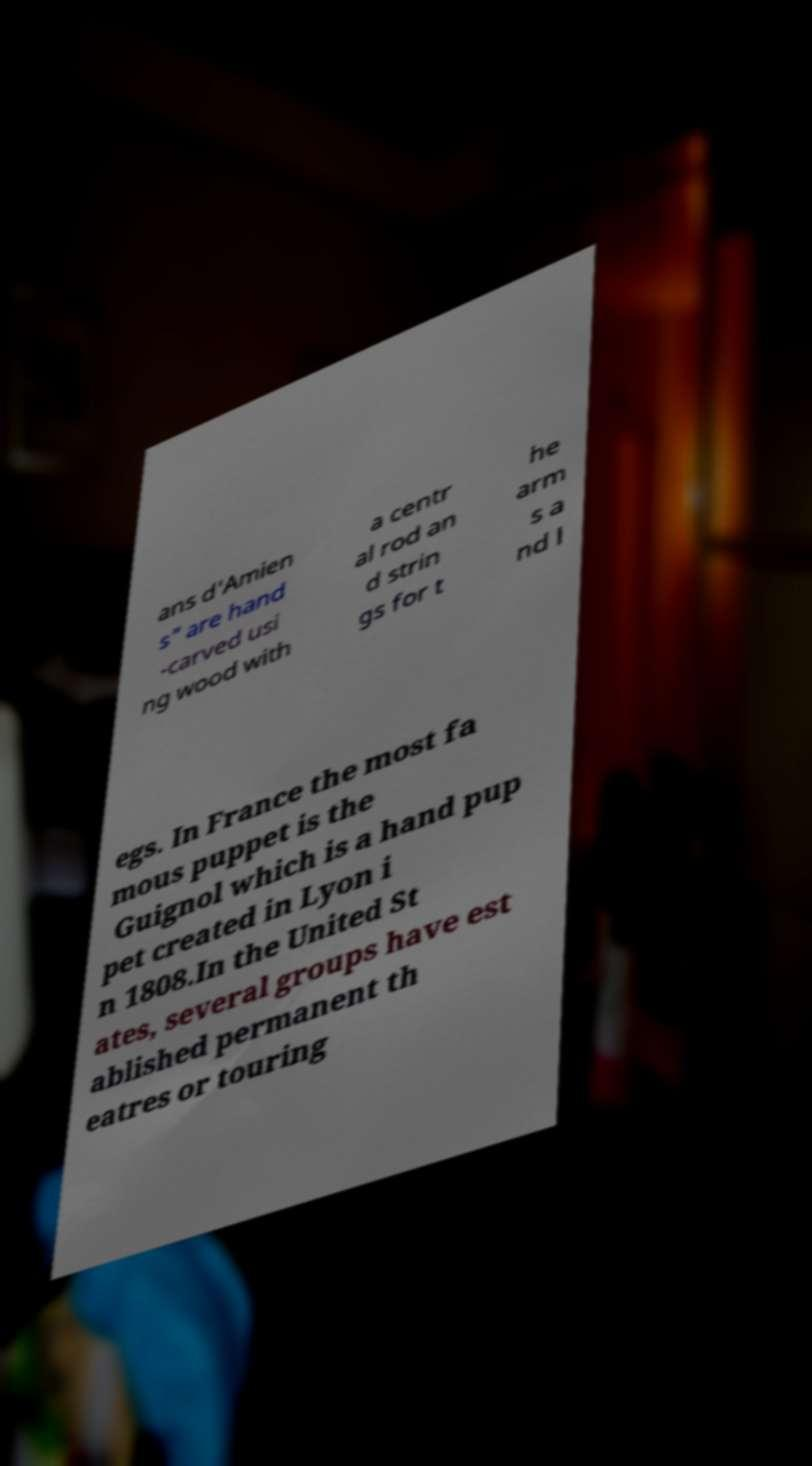What messages or text are displayed in this image? I need them in a readable, typed format. ans d'Amien s" are hand -carved usi ng wood with a centr al rod an d strin gs for t he arm s a nd l egs. In France the most fa mous puppet is the Guignol which is a hand pup pet created in Lyon i n 1808.In the United St ates, several groups have est ablished permanent th eatres or touring 